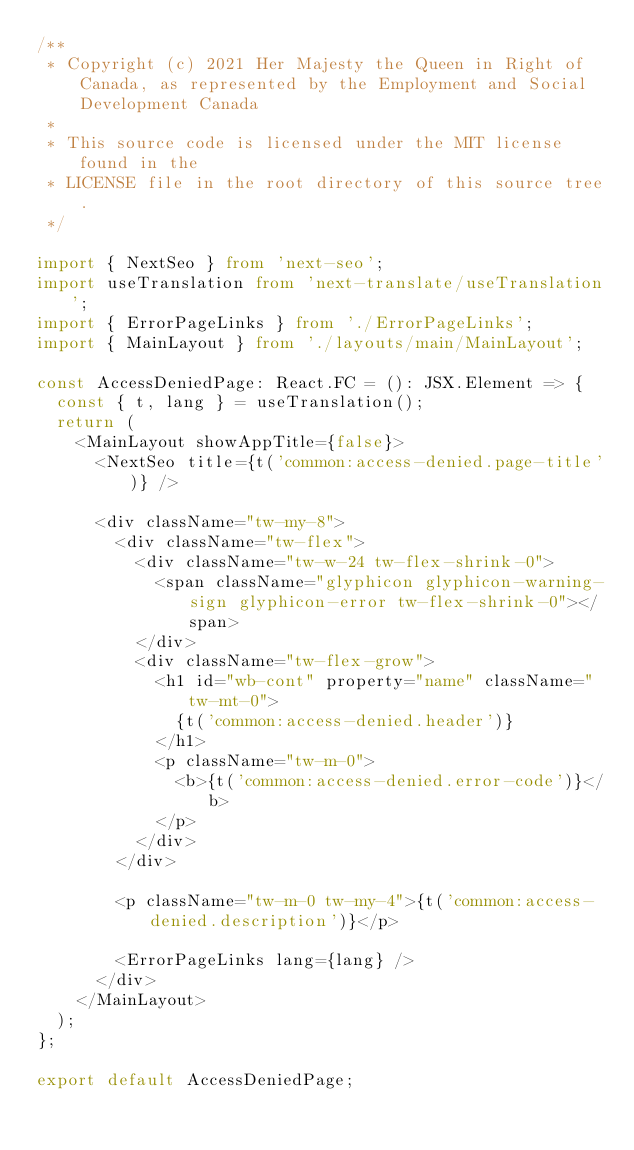<code> <loc_0><loc_0><loc_500><loc_500><_TypeScript_>/**
 * Copyright (c) 2021 Her Majesty the Queen in Right of Canada, as represented by the Employment and Social Development Canada
 *
 * This source code is licensed under the MIT license found in the
 * LICENSE file in the root directory of this source tree.
 */

import { NextSeo } from 'next-seo';
import useTranslation from 'next-translate/useTranslation';
import { ErrorPageLinks } from './ErrorPageLinks';
import { MainLayout } from './layouts/main/MainLayout';

const AccessDeniedPage: React.FC = (): JSX.Element => {
  const { t, lang } = useTranslation();
  return (
    <MainLayout showAppTitle={false}>
      <NextSeo title={t('common:access-denied.page-title')} />

      <div className="tw-my-8">
        <div className="tw-flex">
          <div className="tw-w-24 tw-flex-shrink-0">
            <span className="glyphicon glyphicon-warning-sign glyphicon-error tw-flex-shrink-0"></span>
          </div>
          <div className="tw-flex-grow">
            <h1 id="wb-cont" property="name" className="tw-mt-0">
              {t('common:access-denied.header')}
            </h1>
            <p className="tw-m-0">
              <b>{t('common:access-denied.error-code')}</b>
            </p>
          </div>
        </div>

        <p className="tw-m-0 tw-my-4">{t('common:access-denied.description')}</p>

        <ErrorPageLinks lang={lang} />
      </div>
    </MainLayout>
  );
};

export default AccessDeniedPage;
</code> 